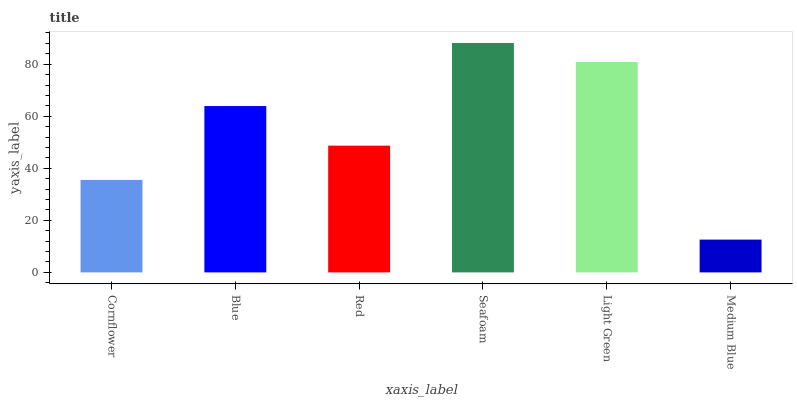Is Medium Blue the minimum?
Answer yes or no. Yes. Is Seafoam the maximum?
Answer yes or no. Yes. Is Blue the minimum?
Answer yes or no. No. Is Blue the maximum?
Answer yes or no. No. Is Blue greater than Cornflower?
Answer yes or no. Yes. Is Cornflower less than Blue?
Answer yes or no. Yes. Is Cornflower greater than Blue?
Answer yes or no. No. Is Blue less than Cornflower?
Answer yes or no. No. Is Blue the high median?
Answer yes or no. Yes. Is Red the low median?
Answer yes or no. Yes. Is Medium Blue the high median?
Answer yes or no. No. Is Seafoam the low median?
Answer yes or no. No. 